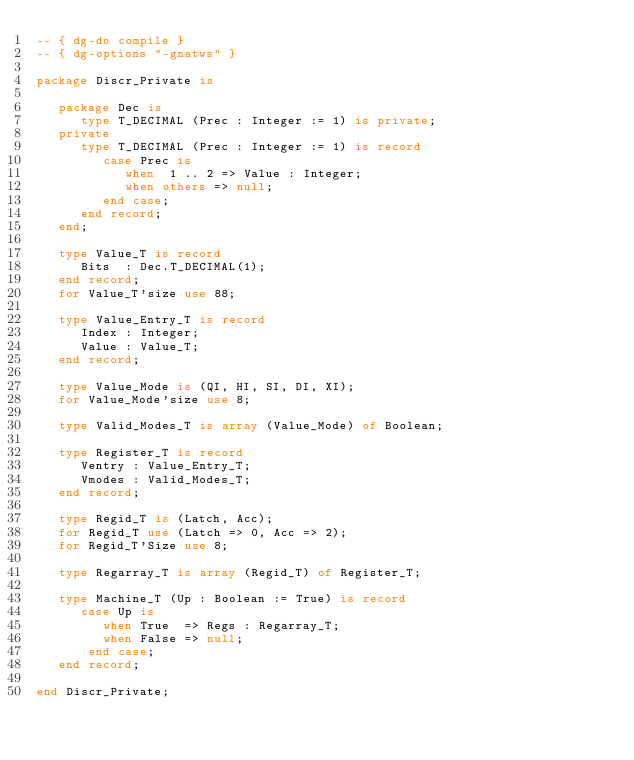Convert code to text. <code><loc_0><loc_0><loc_500><loc_500><_Ada_>-- { dg-do compile }
-- { dg-options "-gnatws" }

package Discr_Private is

   package Dec is
      type T_DECIMAL (Prec : Integer := 1) is private;
   private
      type T_DECIMAL (Prec : Integer := 1) is record
         case Prec is
            when  1 .. 2 => Value : Integer;
            when others => null;
         end case;
      end record;
   end;

   type Value_T is record
      Bits  : Dec.T_DECIMAL(1);
   end record;
   for Value_T'size use 88;

   type Value_Entry_T is record
      Index : Integer;
      Value : Value_T;
   end record;

   type Value_Mode is (QI, HI, SI, DI, XI);
   for Value_Mode'size use 8;

   type Valid_Modes_T is array (Value_Mode) of Boolean;

   type Register_T is record
      Ventry : Value_Entry_T;
      Vmodes : Valid_Modes_T;
   end record;

   type Regid_T is (Latch, Acc);
   for Regid_T use (Latch => 0, Acc => 2);
   for Regid_T'Size use 8;

   type Regarray_T is array (Regid_T) of Register_T;

   type Machine_T (Up : Boolean := True) is record
      case Up is
         when True  => Regs : Regarray_T;
         when False => null;
       end case;
   end record;

end Discr_Private;
</code> 